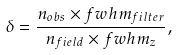Convert formula to latex. <formula><loc_0><loc_0><loc_500><loc_500>\delta = \frac { n _ { o b s } \times f w h m _ { f i l t e r } } { n _ { f i e l d } \times f w h m _ { z } } ,</formula> 